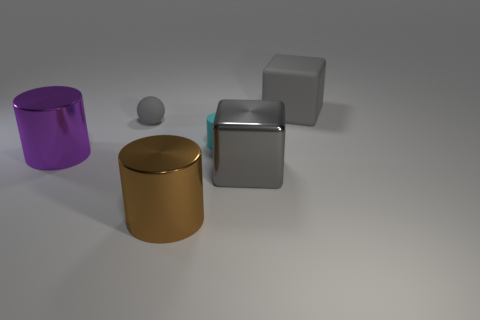Is there any source of light visible in this image? No direct source of light is visible, but we can infer a light source from the reflections and shadows. The objects have highlights and shadows indicating that light is coming from the upper left, possibly out of frame. 